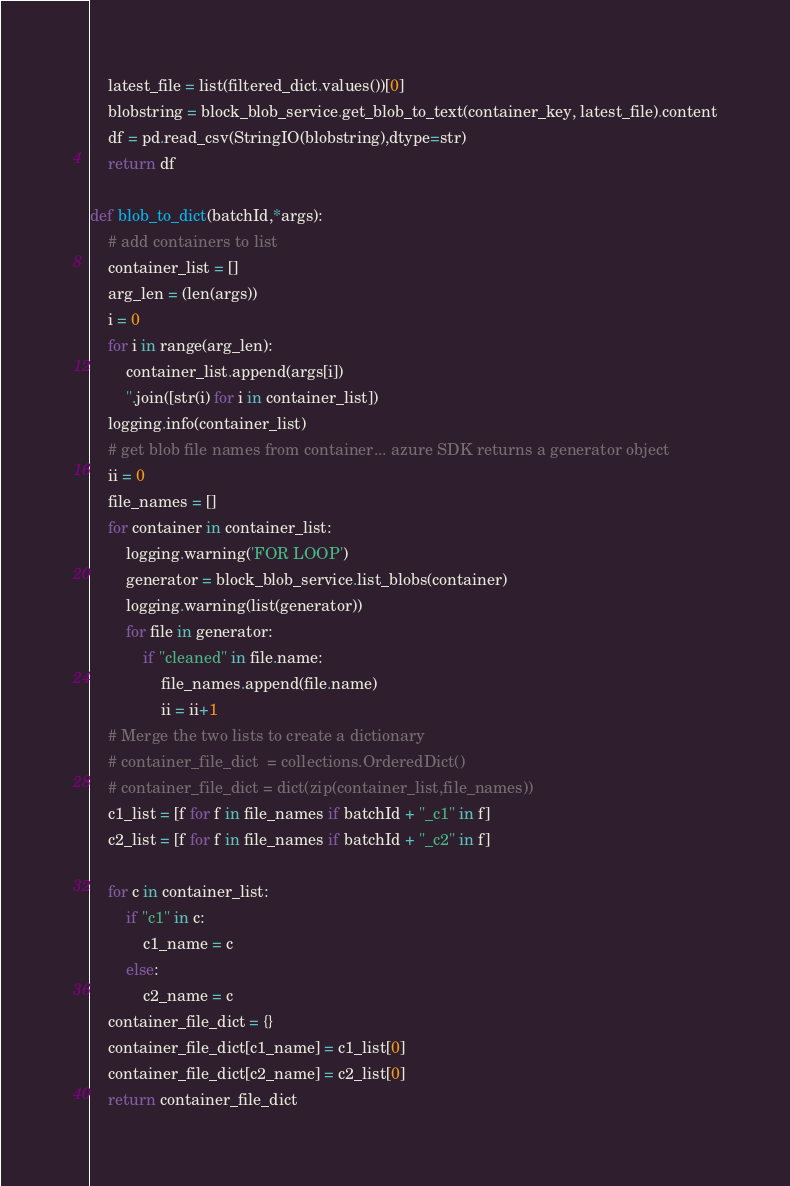<code> <loc_0><loc_0><loc_500><loc_500><_Python_>    latest_file = list(filtered_dict.values())[0]
    blobstring = block_blob_service.get_blob_to_text(container_key, latest_file).content
    df = pd.read_csv(StringIO(blobstring),dtype=str)
    return df

def blob_to_dict(batchId,*args):
    # add containers to list
    container_list = []
    arg_len = (len(args))
    i = 0
    for i in range(arg_len):
        container_list.append(args[i])
        ''.join([str(i) for i in container_list])
    logging.info(container_list)
    # get blob file names from container... azure SDK returns a generator object
    ii = 0
    file_names = []
    for container in container_list:
        logging.warning('FOR LOOP')
        generator = block_blob_service.list_blobs(container)
        logging.warning(list(generator))
        for file in generator:
            if "cleaned" in file.name:
                file_names.append(file.name)
                ii = ii+1
    # Merge the two lists to create a dictionary
    # container_file_dict  = collections.OrderedDict()
    # container_file_dict = dict(zip(container_list,file_names))
    c1_list = [f for f in file_names if batchId + "_c1" in f]
    c2_list = [f for f in file_names if batchId + "_c2" in f]

    for c in container_list:
        if "c1" in c:
            c1_name = c
        else:
            c2_name = c
    container_file_dict = {}
    container_file_dict[c1_name] = c1_list[0]
    container_file_dict[c2_name] = c2_list[0]
    return container_file_dict
</code> 